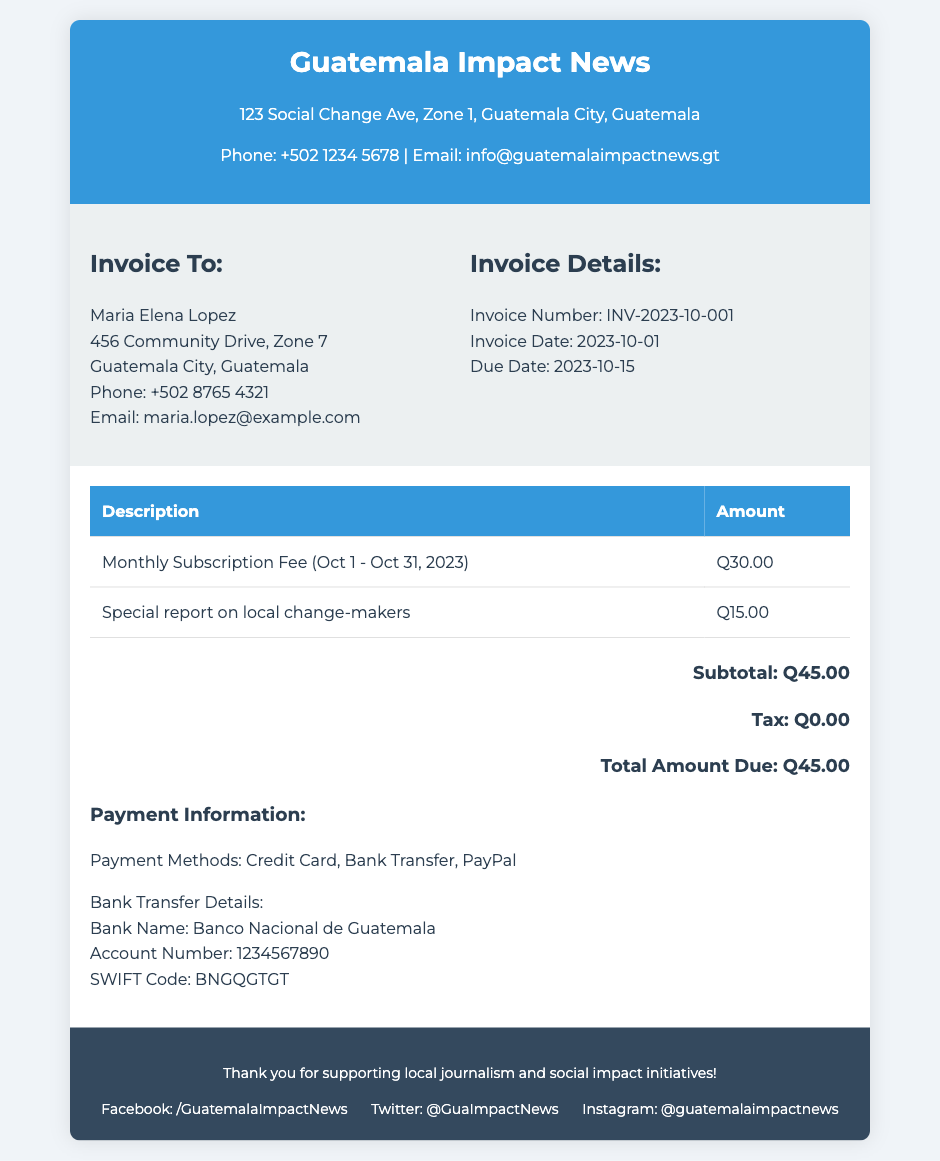What is the invoice number? The invoice number is provided in the document as part of the invoice details section.
Answer: INV-2023-10-001 Who is the invoice addressed to? The document includes a section with the recipient's details, which states the name of the person receiving the invoice.
Answer: Maria Elena Lopez What is the total amount due? The total amount due is calculated by the subtotal and any applicable taxes, shown prominently in the document.
Answer: Q45.00 When is the invoice due date? The due date is listed in the invoice details section, indicating when payment is expected.
Answer: 2023-10-15 What payment methods are accepted? The document specifies the payment methods available for the transaction in the payment information section.
Answer: Credit Card, Bank Transfer, PayPal What time period does the monthly subscription fee cover? The time period for the subscription fee is detailed in the document's billing section for clarity.
Answer: Oct 1 - Oct 31, 2023 What is the subtotal of the invoice? The subtotal is the total before tax and is detailed in the pricing table within the document.
Answer: Q45.00 Who issued the invoice? The footer of the document mentions the name of the organization that issued the invoice, reflecting the source of the invoice.
Answer: Guatemala Impact News 